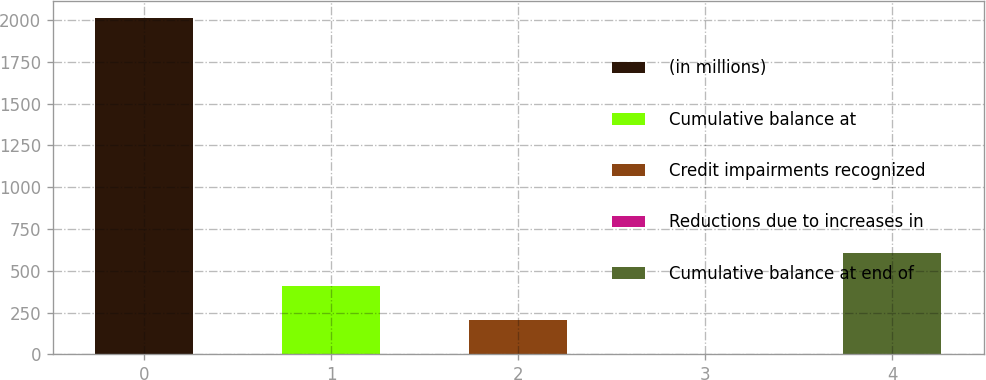Convert chart. <chart><loc_0><loc_0><loc_500><loc_500><bar_chart><fcel>(in millions)<fcel>Cumulative balance at<fcel>Credit impairments recognized<fcel>Reductions due to increases in<fcel>Cumulative balance at end of<nl><fcel>2014<fcel>406<fcel>205<fcel>4<fcel>607<nl></chart> 